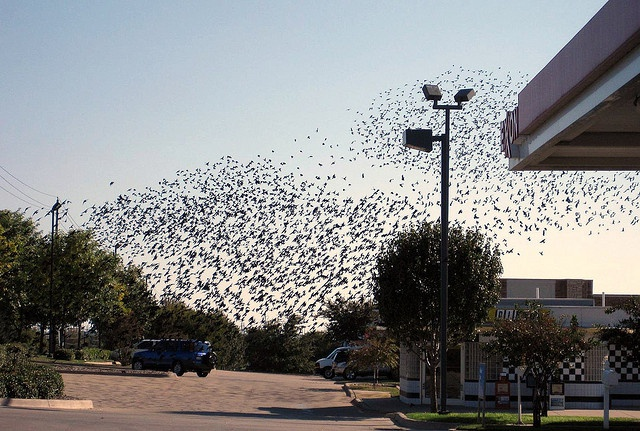Describe the objects in this image and their specific colors. I can see bird in darkgray, lightgray, black, and gray tones, car in darkgray, black, navy, gray, and darkblue tones, car in darkgray, black, and gray tones, car in darkgray, black, and gray tones, and car in darkgray, black, gray, and blue tones in this image. 